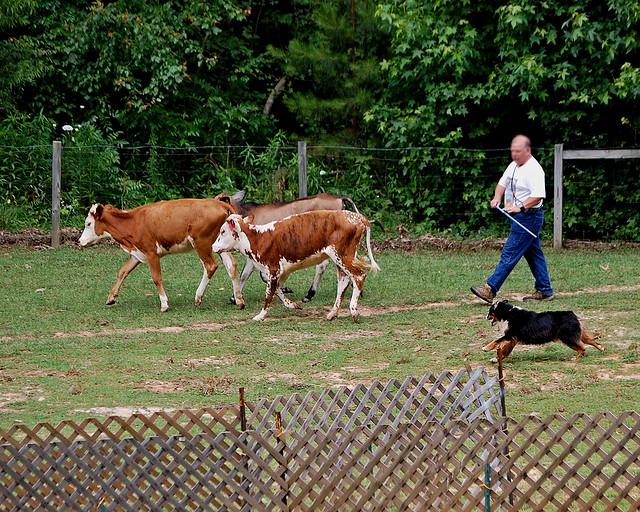How many cattle are shown in this scene?
Keep it brief. 3. How old is the dog?
Be succinct. 2. How many cows are there?
Short answer required. 3. Are these cows full-grown?
Keep it brief. No. 